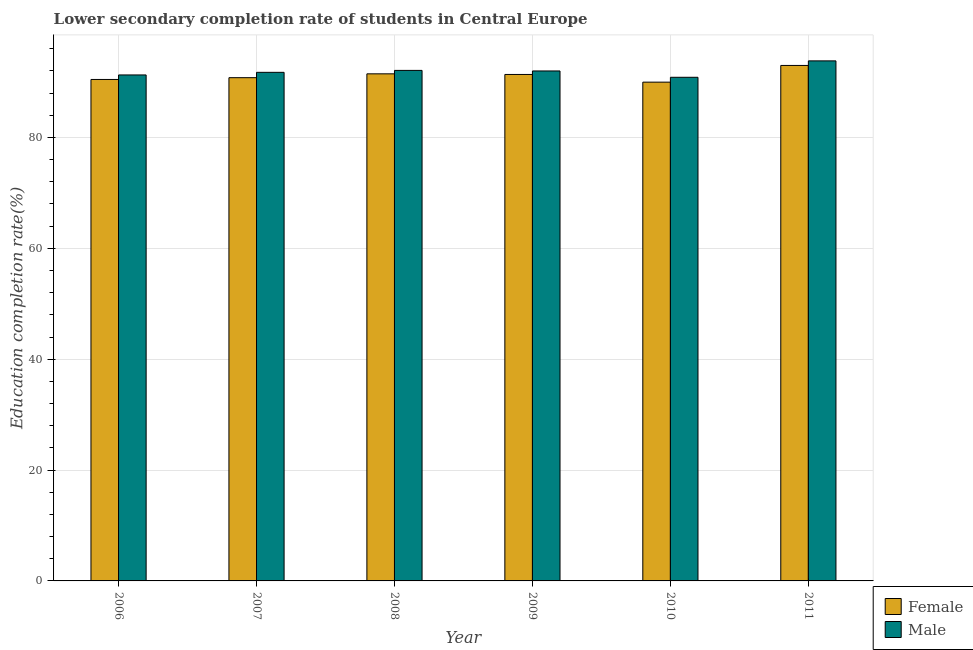Are the number of bars per tick equal to the number of legend labels?
Make the answer very short. Yes. How many bars are there on the 1st tick from the left?
Make the answer very short. 2. How many bars are there on the 5th tick from the right?
Keep it short and to the point. 2. What is the label of the 1st group of bars from the left?
Keep it short and to the point. 2006. In how many cases, is the number of bars for a given year not equal to the number of legend labels?
Your response must be concise. 0. What is the education completion rate of female students in 2010?
Provide a short and direct response. 89.98. Across all years, what is the maximum education completion rate of female students?
Keep it short and to the point. 92.99. Across all years, what is the minimum education completion rate of female students?
Offer a very short reply. 89.98. What is the total education completion rate of male students in the graph?
Give a very brief answer. 551.78. What is the difference between the education completion rate of male students in 2007 and that in 2010?
Give a very brief answer. 0.89. What is the difference between the education completion rate of female students in 2008 and the education completion rate of male students in 2010?
Offer a terse response. 1.5. What is the average education completion rate of male students per year?
Provide a succinct answer. 91.96. In how many years, is the education completion rate of female students greater than 92 %?
Keep it short and to the point. 1. What is the ratio of the education completion rate of male students in 2009 to that in 2010?
Provide a short and direct response. 1.01. Is the education completion rate of male students in 2007 less than that in 2011?
Give a very brief answer. Yes. Is the difference between the education completion rate of female students in 2006 and 2010 greater than the difference between the education completion rate of male students in 2006 and 2010?
Offer a very short reply. No. What is the difference between the highest and the second highest education completion rate of female students?
Make the answer very short. 1.51. What is the difference between the highest and the lowest education completion rate of male students?
Your response must be concise. 2.96. In how many years, is the education completion rate of female students greater than the average education completion rate of female students taken over all years?
Give a very brief answer. 3. What does the 1st bar from the right in 2008 represents?
Offer a terse response. Male. How many bars are there?
Offer a terse response. 12. What is the difference between two consecutive major ticks on the Y-axis?
Offer a terse response. 20. Where does the legend appear in the graph?
Your response must be concise. Bottom right. How many legend labels are there?
Provide a succinct answer. 2. How are the legend labels stacked?
Your response must be concise. Vertical. What is the title of the graph?
Give a very brief answer. Lower secondary completion rate of students in Central Europe. What is the label or title of the X-axis?
Make the answer very short. Year. What is the label or title of the Y-axis?
Ensure brevity in your answer.  Education completion rate(%). What is the Education completion rate(%) of Female in 2006?
Keep it short and to the point. 90.46. What is the Education completion rate(%) in Male in 2006?
Your answer should be compact. 91.27. What is the Education completion rate(%) of Female in 2007?
Provide a short and direct response. 90.78. What is the Education completion rate(%) in Male in 2007?
Offer a very short reply. 91.75. What is the Education completion rate(%) of Female in 2008?
Offer a very short reply. 91.48. What is the Education completion rate(%) of Male in 2008?
Your response must be concise. 92.1. What is the Education completion rate(%) of Female in 2009?
Your answer should be compact. 91.36. What is the Education completion rate(%) in Male in 2009?
Give a very brief answer. 91.99. What is the Education completion rate(%) of Female in 2010?
Your answer should be very brief. 89.98. What is the Education completion rate(%) of Male in 2010?
Provide a short and direct response. 90.85. What is the Education completion rate(%) in Female in 2011?
Give a very brief answer. 92.99. What is the Education completion rate(%) in Male in 2011?
Provide a succinct answer. 93.81. Across all years, what is the maximum Education completion rate(%) of Female?
Your response must be concise. 92.99. Across all years, what is the maximum Education completion rate(%) of Male?
Offer a terse response. 93.81. Across all years, what is the minimum Education completion rate(%) of Female?
Your answer should be compact. 89.98. Across all years, what is the minimum Education completion rate(%) in Male?
Ensure brevity in your answer.  90.85. What is the total Education completion rate(%) in Female in the graph?
Provide a short and direct response. 547.04. What is the total Education completion rate(%) in Male in the graph?
Your response must be concise. 551.78. What is the difference between the Education completion rate(%) in Female in 2006 and that in 2007?
Offer a very short reply. -0.32. What is the difference between the Education completion rate(%) in Male in 2006 and that in 2007?
Provide a short and direct response. -0.47. What is the difference between the Education completion rate(%) of Female in 2006 and that in 2008?
Provide a short and direct response. -1.02. What is the difference between the Education completion rate(%) of Male in 2006 and that in 2008?
Your answer should be compact. -0.82. What is the difference between the Education completion rate(%) in Female in 2006 and that in 2009?
Make the answer very short. -0.9. What is the difference between the Education completion rate(%) of Male in 2006 and that in 2009?
Offer a terse response. -0.72. What is the difference between the Education completion rate(%) in Female in 2006 and that in 2010?
Provide a succinct answer. 0.49. What is the difference between the Education completion rate(%) of Male in 2006 and that in 2010?
Ensure brevity in your answer.  0.42. What is the difference between the Education completion rate(%) of Female in 2006 and that in 2011?
Your response must be concise. -2.53. What is the difference between the Education completion rate(%) of Male in 2006 and that in 2011?
Provide a short and direct response. -2.54. What is the difference between the Education completion rate(%) of Female in 2007 and that in 2008?
Your answer should be compact. -0.69. What is the difference between the Education completion rate(%) of Male in 2007 and that in 2008?
Ensure brevity in your answer.  -0.35. What is the difference between the Education completion rate(%) in Female in 2007 and that in 2009?
Your response must be concise. -0.58. What is the difference between the Education completion rate(%) of Male in 2007 and that in 2009?
Your answer should be compact. -0.25. What is the difference between the Education completion rate(%) of Female in 2007 and that in 2010?
Ensure brevity in your answer.  0.81. What is the difference between the Education completion rate(%) of Male in 2007 and that in 2010?
Offer a terse response. 0.89. What is the difference between the Education completion rate(%) of Female in 2007 and that in 2011?
Provide a succinct answer. -2.21. What is the difference between the Education completion rate(%) in Male in 2007 and that in 2011?
Give a very brief answer. -2.07. What is the difference between the Education completion rate(%) of Female in 2008 and that in 2009?
Keep it short and to the point. 0.11. What is the difference between the Education completion rate(%) in Male in 2008 and that in 2009?
Make the answer very short. 0.1. What is the difference between the Education completion rate(%) of Female in 2008 and that in 2010?
Keep it short and to the point. 1.5. What is the difference between the Education completion rate(%) in Male in 2008 and that in 2010?
Your answer should be very brief. 1.24. What is the difference between the Education completion rate(%) in Female in 2008 and that in 2011?
Make the answer very short. -1.51. What is the difference between the Education completion rate(%) of Male in 2008 and that in 2011?
Your answer should be very brief. -1.72. What is the difference between the Education completion rate(%) in Female in 2009 and that in 2010?
Provide a short and direct response. 1.39. What is the difference between the Education completion rate(%) in Male in 2009 and that in 2010?
Your response must be concise. 1.14. What is the difference between the Education completion rate(%) in Female in 2009 and that in 2011?
Provide a short and direct response. -1.63. What is the difference between the Education completion rate(%) of Male in 2009 and that in 2011?
Offer a very short reply. -1.82. What is the difference between the Education completion rate(%) of Female in 2010 and that in 2011?
Offer a terse response. -3.01. What is the difference between the Education completion rate(%) of Male in 2010 and that in 2011?
Provide a succinct answer. -2.96. What is the difference between the Education completion rate(%) in Female in 2006 and the Education completion rate(%) in Male in 2007?
Provide a succinct answer. -1.29. What is the difference between the Education completion rate(%) in Female in 2006 and the Education completion rate(%) in Male in 2008?
Your response must be concise. -1.63. What is the difference between the Education completion rate(%) in Female in 2006 and the Education completion rate(%) in Male in 2009?
Keep it short and to the point. -1.53. What is the difference between the Education completion rate(%) in Female in 2006 and the Education completion rate(%) in Male in 2010?
Offer a terse response. -0.39. What is the difference between the Education completion rate(%) in Female in 2006 and the Education completion rate(%) in Male in 2011?
Provide a short and direct response. -3.35. What is the difference between the Education completion rate(%) of Female in 2007 and the Education completion rate(%) of Male in 2008?
Offer a terse response. -1.31. What is the difference between the Education completion rate(%) of Female in 2007 and the Education completion rate(%) of Male in 2009?
Provide a short and direct response. -1.21. What is the difference between the Education completion rate(%) of Female in 2007 and the Education completion rate(%) of Male in 2010?
Your answer should be compact. -0.07. What is the difference between the Education completion rate(%) of Female in 2007 and the Education completion rate(%) of Male in 2011?
Ensure brevity in your answer.  -3.03. What is the difference between the Education completion rate(%) in Female in 2008 and the Education completion rate(%) in Male in 2009?
Ensure brevity in your answer.  -0.52. What is the difference between the Education completion rate(%) of Female in 2008 and the Education completion rate(%) of Male in 2010?
Make the answer very short. 0.62. What is the difference between the Education completion rate(%) in Female in 2008 and the Education completion rate(%) in Male in 2011?
Provide a short and direct response. -2.34. What is the difference between the Education completion rate(%) in Female in 2009 and the Education completion rate(%) in Male in 2010?
Offer a very short reply. 0.51. What is the difference between the Education completion rate(%) of Female in 2009 and the Education completion rate(%) of Male in 2011?
Give a very brief answer. -2.45. What is the difference between the Education completion rate(%) of Female in 2010 and the Education completion rate(%) of Male in 2011?
Give a very brief answer. -3.84. What is the average Education completion rate(%) in Female per year?
Give a very brief answer. 91.17. What is the average Education completion rate(%) of Male per year?
Make the answer very short. 91.96. In the year 2006, what is the difference between the Education completion rate(%) of Female and Education completion rate(%) of Male?
Your response must be concise. -0.81. In the year 2007, what is the difference between the Education completion rate(%) in Female and Education completion rate(%) in Male?
Provide a succinct answer. -0.97. In the year 2008, what is the difference between the Education completion rate(%) of Female and Education completion rate(%) of Male?
Provide a succinct answer. -0.62. In the year 2009, what is the difference between the Education completion rate(%) in Female and Education completion rate(%) in Male?
Make the answer very short. -0.63. In the year 2010, what is the difference between the Education completion rate(%) in Female and Education completion rate(%) in Male?
Your answer should be compact. -0.88. In the year 2011, what is the difference between the Education completion rate(%) in Female and Education completion rate(%) in Male?
Your answer should be very brief. -0.83. What is the ratio of the Education completion rate(%) in Female in 2006 to that in 2008?
Provide a succinct answer. 0.99. What is the ratio of the Education completion rate(%) in Female in 2006 to that in 2010?
Your answer should be compact. 1.01. What is the ratio of the Education completion rate(%) in Male in 2006 to that in 2010?
Provide a short and direct response. 1. What is the ratio of the Education completion rate(%) in Female in 2006 to that in 2011?
Provide a succinct answer. 0.97. What is the ratio of the Education completion rate(%) of Male in 2006 to that in 2011?
Your answer should be very brief. 0.97. What is the ratio of the Education completion rate(%) in Female in 2007 to that in 2008?
Offer a terse response. 0.99. What is the ratio of the Education completion rate(%) of Male in 2007 to that in 2009?
Your answer should be compact. 1. What is the ratio of the Education completion rate(%) in Male in 2007 to that in 2010?
Give a very brief answer. 1.01. What is the ratio of the Education completion rate(%) in Female in 2007 to that in 2011?
Your answer should be compact. 0.98. What is the ratio of the Education completion rate(%) of Female in 2008 to that in 2010?
Offer a very short reply. 1.02. What is the ratio of the Education completion rate(%) of Male in 2008 to that in 2010?
Offer a very short reply. 1.01. What is the ratio of the Education completion rate(%) in Female in 2008 to that in 2011?
Make the answer very short. 0.98. What is the ratio of the Education completion rate(%) of Male in 2008 to that in 2011?
Offer a terse response. 0.98. What is the ratio of the Education completion rate(%) of Female in 2009 to that in 2010?
Your answer should be very brief. 1.02. What is the ratio of the Education completion rate(%) of Male in 2009 to that in 2010?
Ensure brevity in your answer.  1.01. What is the ratio of the Education completion rate(%) in Female in 2009 to that in 2011?
Provide a short and direct response. 0.98. What is the ratio of the Education completion rate(%) of Male in 2009 to that in 2011?
Provide a short and direct response. 0.98. What is the ratio of the Education completion rate(%) in Female in 2010 to that in 2011?
Provide a short and direct response. 0.97. What is the ratio of the Education completion rate(%) of Male in 2010 to that in 2011?
Ensure brevity in your answer.  0.97. What is the difference between the highest and the second highest Education completion rate(%) of Female?
Provide a short and direct response. 1.51. What is the difference between the highest and the second highest Education completion rate(%) of Male?
Provide a short and direct response. 1.72. What is the difference between the highest and the lowest Education completion rate(%) of Female?
Provide a succinct answer. 3.01. What is the difference between the highest and the lowest Education completion rate(%) of Male?
Ensure brevity in your answer.  2.96. 